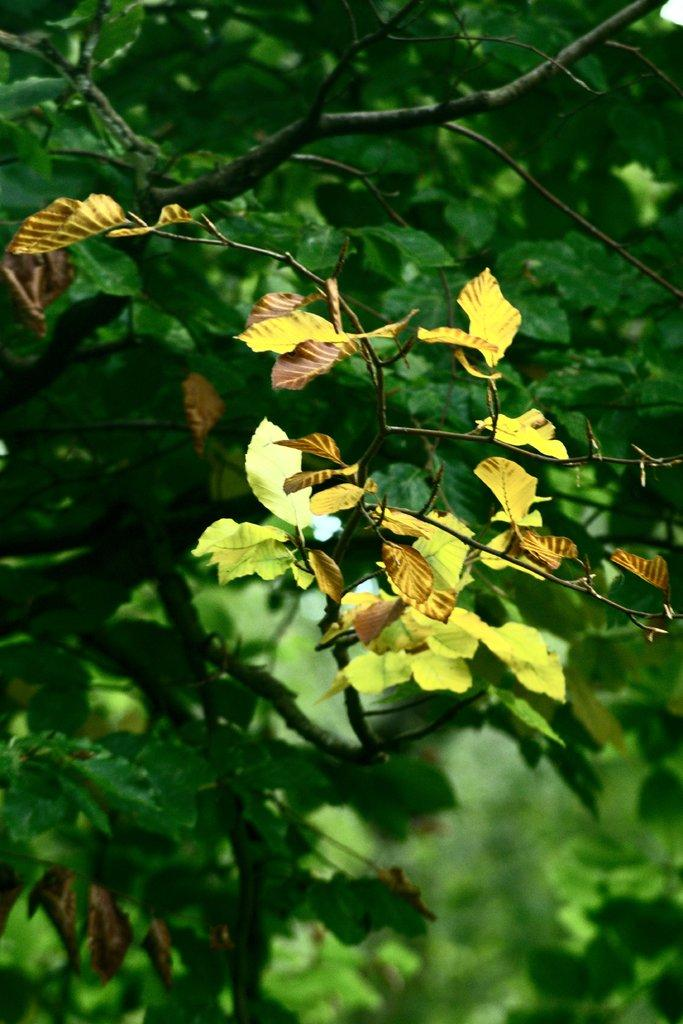What colors can be seen in the leaves in the image? There are yellow and green leaves in the image. What else can be seen besides the leaves in the image? There are stems visible in the image. Whose hair can be seen in the image? There is no hair visible in the image; it features leaves and stems. Who is the creator of the leaves in the image? The leaves in the image are natural plant parts and not created by a specific person. 